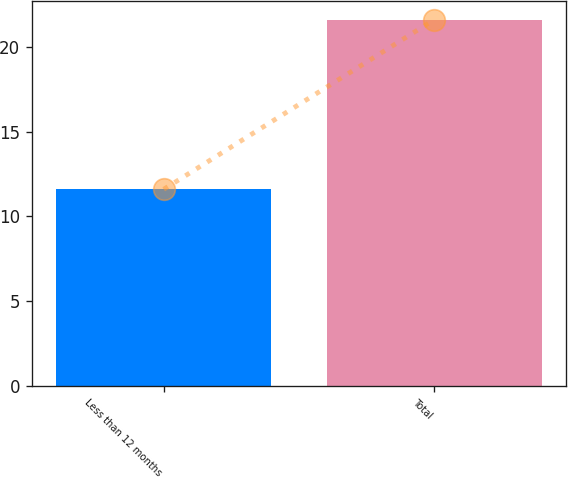<chart> <loc_0><loc_0><loc_500><loc_500><bar_chart><fcel>Less than 12 months<fcel>Total<nl><fcel>11.6<fcel>21.6<nl></chart> 